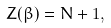Convert formula to latex. <formula><loc_0><loc_0><loc_500><loc_500>Z ( \beta ) = N + 1 ,</formula> 